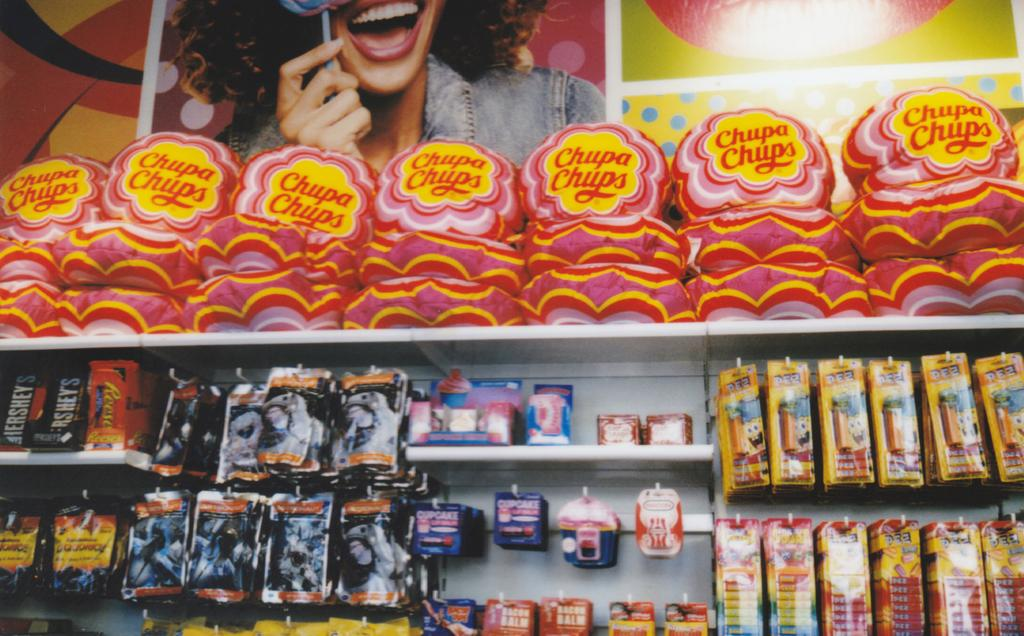What type of establishment is depicted in the image? There is a store in the image. What products can be found in the store? Chocolates are available in the store. Can you describe the lady in the image? There is a lady holding a chocolate in the image, and she is smiling. What else can be found in the store besides chocolates? There are other items available in the store. What color is the shade covering the cars in the image? There are no cars or shades present in the image; it features a store with a lady holding a chocolate. 